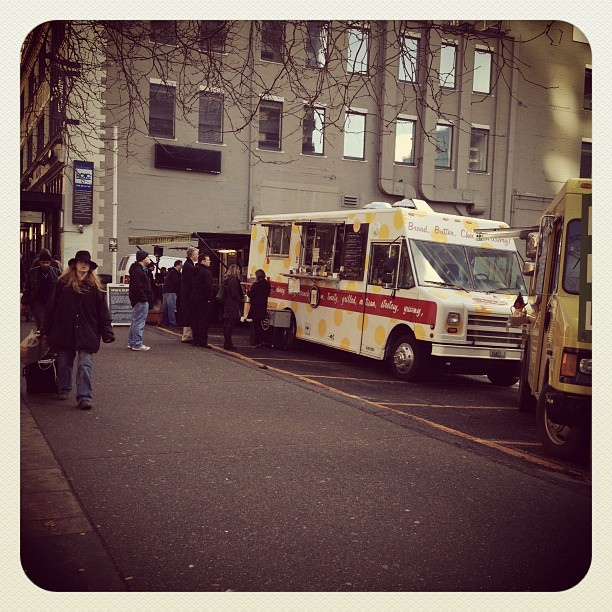<image>How many beams are on the ceiling? It is unknown how many beams are on the ceiling. What color is the lady's bonnet? The lady's bonnet is black. However, it could also be possible that there is no bonnet. What kind of mirror is this? I am not sure about the type of mirror in the image, but there may be a side view mirror. Is it summertime? No, it is not summertime. How many beams are on the ceiling? There are no beams on the ceiling. What color is the lady's bonnet? The lady's bonnet is black. Is it summertime? It is not summertime. What kind of mirror is this? I don't know what kind of mirror it is. It can be a shape, glass, truck mirror, side mirror, reflective mirror, convex mirror, or reflecting mirror. 